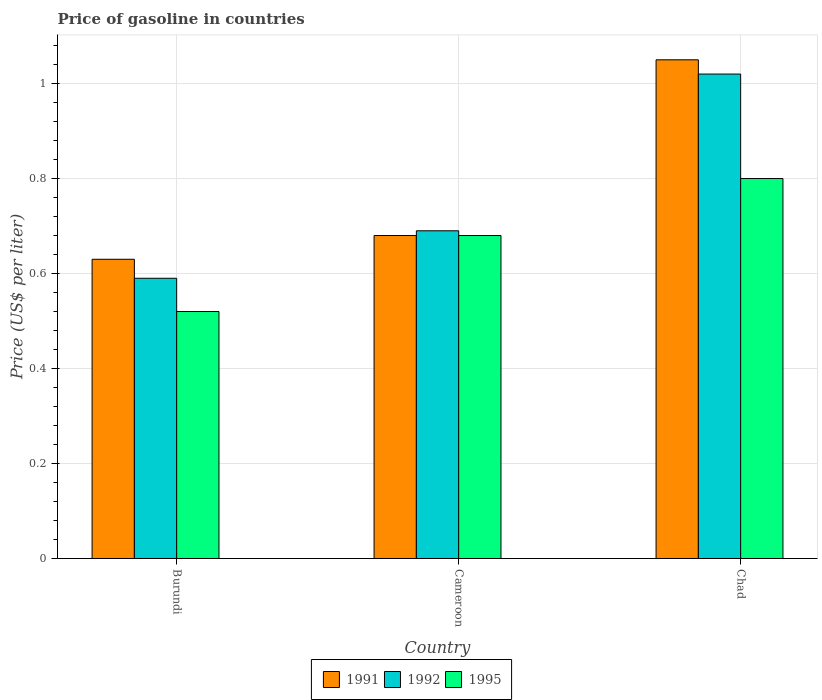How many different coloured bars are there?
Provide a succinct answer. 3. Are the number of bars per tick equal to the number of legend labels?
Offer a terse response. Yes. Are the number of bars on each tick of the X-axis equal?
Your answer should be very brief. Yes. How many bars are there on the 3rd tick from the left?
Offer a very short reply. 3. How many bars are there on the 1st tick from the right?
Provide a short and direct response. 3. What is the label of the 3rd group of bars from the left?
Make the answer very short. Chad. What is the price of gasoline in 1992 in Burundi?
Give a very brief answer. 0.59. Across all countries, what is the minimum price of gasoline in 1995?
Offer a terse response. 0.52. In which country was the price of gasoline in 1991 maximum?
Ensure brevity in your answer.  Chad. In which country was the price of gasoline in 1995 minimum?
Your answer should be very brief. Burundi. What is the total price of gasoline in 1991 in the graph?
Your answer should be very brief. 2.36. What is the difference between the price of gasoline in 1995 in Burundi and that in Cameroon?
Offer a terse response. -0.16. What is the difference between the price of gasoline in 1992 in Burundi and the price of gasoline in 1991 in Chad?
Keep it short and to the point. -0.46. What is the average price of gasoline in 1992 per country?
Provide a short and direct response. 0.77. What is the difference between the price of gasoline of/in 1991 and price of gasoline of/in 1995 in Chad?
Make the answer very short. 0.25. What is the ratio of the price of gasoline in 1991 in Burundi to that in Cameroon?
Offer a very short reply. 0.93. Is the price of gasoline in 1992 in Burundi less than that in Chad?
Your answer should be compact. Yes. What is the difference between the highest and the second highest price of gasoline in 1992?
Offer a terse response. -0.33. What is the difference between the highest and the lowest price of gasoline in 1991?
Keep it short and to the point. 0.42. In how many countries, is the price of gasoline in 1991 greater than the average price of gasoline in 1991 taken over all countries?
Make the answer very short. 1. Is the sum of the price of gasoline in 1991 in Burundi and Chad greater than the maximum price of gasoline in 1992 across all countries?
Keep it short and to the point. Yes. What does the 1st bar from the right in Cameroon represents?
Make the answer very short. 1995. Is it the case that in every country, the sum of the price of gasoline in 1991 and price of gasoline in 1992 is greater than the price of gasoline in 1995?
Provide a short and direct response. Yes. How many countries are there in the graph?
Provide a short and direct response. 3. Does the graph contain grids?
Your answer should be very brief. Yes. Where does the legend appear in the graph?
Your response must be concise. Bottom center. How many legend labels are there?
Offer a very short reply. 3. How are the legend labels stacked?
Offer a very short reply. Horizontal. What is the title of the graph?
Offer a terse response. Price of gasoline in countries. Does "1969" appear as one of the legend labels in the graph?
Provide a succinct answer. No. What is the label or title of the X-axis?
Offer a very short reply. Country. What is the label or title of the Y-axis?
Keep it short and to the point. Price (US$ per liter). What is the Price (US$ per liter) in 1991 in Burundi?
Your answer should be compact. 0.63. What is the Price (US$ per liter) of 1992 in Burundi?
Ensure brevity in your answer.  0.59. What is the Price (US$ per liter) of 1995 in Burundi?
Keep it short and to the point. 0.52. What is the Price (US$ per liter) of 1991 in Cameroon?
Offer a very short reply. 0.68. What is the Price (US$ per liter) in 1992 in Cameroon?
Ensure brevity in your answer.  0.69. What is the Price (US$ per liter) in 1995 in Cameroon?
Offer a very short reply. 0.68. What is the Price (US$ per liter) in 1991 in Chad?
Offer a terse response. 1.05. Across all countries, what is the maximum Price (US$ per liter) of 1995?
Make the answer very short. 0.8. Across all countries, what is the minimum Price (US$ per liter) of 1991?
Your answer should be very brief. 0.63. Across all countries, what is the minimum Price (US$ per liter) in 1992?
Make the answer very short. 0.59. Across all countries, what is the minimum Price (US$ per liter) of 1995?
Your answer should be compact. 0.52. What is the total Price (US$ per liter) in 1991 in the graph?
Your answer should be compact. 2.36. What is the total Price (US$ per liter) in 1995 in the graph?
Ensure brevity in your answer.  2. What is the difference between the Price (US$ per liter) in 1991 in Burundi and that in Cameroon?
Give a very brief answer. -0.05. What is the difference between the Price (US$ per liter) in 1992 in Burundi and that in Cameroon?
Your response must be concise. -0.1. What is the difference between the Price (US$ per liter) in 1995 in Burundi and that in Cameroon?
Your response must be concise. -0.16. What is the difference between the Price (US$ per liter) of 1991 in Burundi and that in Chad?
Provide a succinct answer. -0.42. What is the difference between the Price (US$ per liter) in 1992 in Burundi and that in Chad?
Offer a terse response. -0.43. What is the difference between the Price (US$ per liter) of 1995 in Burundi and that in Chad?
Offer a very short reply. -0.28. What is the difference between the Price (US$ per liter) of 1991 in Cameroon and that in Chad?
Provide a short and direct response. -0.37. What is the difference between the Price (US$ per liter) of 1992 in Cameroon and that in Chad?
Your answer should be very brief. -0.33. What is the difference between the Price (US$ per liter) of 1995 in Cameroon and that in Chad?
Offer a terse response. -0.12. What is the difference between the Price (US$ per liter) in 1991 in Burundi and the Price (US$ per liter) in 1992 in Cameroon?
Your response must be concise. -0.06. What is the difference between the Price (US$ per liter) of 1992 in Burundi and the Price (US$ per liter) of 1995 in Cameroon?
Offer a terse response. -0.09. What is the difference between the Price (US$ per liter) of 1991 in Burundi and the Price (US$ per liter) of 1992 in Chad?
Provide a short and direct response. -0.39. What is the difference between the Price (US$ per liter) of 1991 in Burundi and the Price (US$ per liter) of 1995 in Chad?
Make the answer very short. -0.17. What is the difference between the Price (US$ per liter) of 1992 in Burundi and the Price (US$ per liter) of 1995 in Chad?
Your answer should be compact. -0.21. What is the difference between the Price (US$ per liter) in 1991 in Cameroon and the Price (US$ per liter) in 1992 in Chad?
Offer a terse response. -0.34. What is the difference between the Price (US$ per liter) in 1991 in Cameroon and the Price (US$ per liter) in 1995 in Chad?
Offer a terse response. -0.12. What is the difference between the Price (US$ per liter) in 1992 in Cameroon and the Price (US$ per liter) in 1995 in Chad?
Offer a very short reply. -0.11. What is the average Price (US$ per liter) of 1991 per country?
Your response must be concise. 0.79. What is the average Price (US$ per liter) of 1992 per country?
Your answer should be compact. 0.77. What is the difference between the Price (US$ per liter) of 1991 and Price (US$ per liter) of 1995 in Burundi?
Provide a succinct answer. 0.11. What is the difference between the Price (US$ per liter) of 1992 and Price (US$ per liter) of 1995 in Burundi?
Keep it short and to the point. 0.07. What is the difference between the Price (US$ per liter) of 1991 and Price (US$ per liter) of 1992 in Cameroon?
Your answer should be very brief. -0.01. What is the difference between the Price (US$ per liter) of 1992 and Price (US$ per liter) of 1995 in Cameroon?
Your response must be concise. 0.01. What is the difference between the Price (US$ per liter) of 1992 and Price (US$ per liter) of 1995 in Chad?
Give a very brief answer. 0.22. What is the ratio of the Price (US$ per liter) in 1991 in Burundi to that in Cameroon?
Keep it short and to the point. 0.93. What is the ratio of the Price (US$ per liter) of 1992 in Burundi to that in Cameroon?
Offer a very short reply. 0.86. What is the ratio of the Price (US$ per liter) in 1995 in Burundi to that in Cameroon?
Your answer should be compact. 0.76. What is the ratio of the Price (US$ per liter) of 1992 in Burundi to that in Chad?
Your answer should be compact. 0.58. What is the ratio of the Price (US$ per liter) in 1995 in Burundi to that in Chad?
Provide a succinct answer. 0.65. What is the ratio of the Price (US$ per liter) of 1991 in Cameroon to that in Chad?
Provide a short and direct response. 0.65. What is the ratio of the Price (US$ per liter) in 1992 in Cameroon to that in Chad?
Make the answer very short. 0.68. What is the ratio of the Price (US$ per liter) in 1995 in Cameroon to that in Chad?
Your answer should be compact. 0.85. What is the difference between the highest and the second highest Price (US$ per liter) of 1991?
Provide a short and direct response. 0.37. What is the difference between the highest and the second highest Price (US$ per liter) of 1992?
Ensure brevity in your answer.  0.33. What is the difference between the highest and the second highest Price (US$ per liter) in 1995?
Keep it short and to the point. 0.12. What is the difference between the highest and the lowest Price (US$ per liter) of 1991?
Keep it short and to the point. 0.42. What is the difference between the highest and the lowest Price (US$ per liter) of 1992?
Provide a short and direct response. 0.43. What is the difference between the highest and the lowest Price (US$ per liter) in 1995?
Provide a short and direct response. 0.28. 